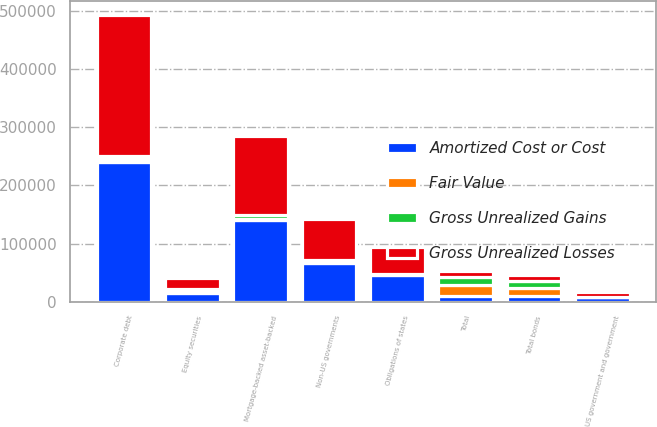<chart> <loc_0><loc_0><loc_500><loc_500><stacked_bar_chart><ecel><fcel>US government and government<fcel>Obligations of states<fcel>Non-US governments<fcel>Corporate debt<fcel>Mortgage-backed asset-backed<fcel>Total bonds<fcel>Equity securities<fcel>Total<nl><fcel>Amortized Cost or Cost<fcel>7956<fcel>46087<fcel>67023<fcel>239822<fcel>140982<fcel>10434.5<fcel>15188<fcel>10434.5<nl><fcel>Fair Value<fcel>333<fcel>927<fcel>3920<fcel>6216<fcel>1221<fcel>12617<fcel>5545<fcel>18162<nl><fcel>Gross Unrealized Gains<fcel>37<fcel>160<fcel>743<fcel>4518<fcel>7703<fcel>13161<fcel>463<fcel>13624<nl><fcel>Gross Unrealized Losses<fcel>8252<fcel>46854<fcel>70200<fcel>241520<fcel>134500<fcel>10434.5<fcel>20270<fcel>10434.5<nl></chart> 